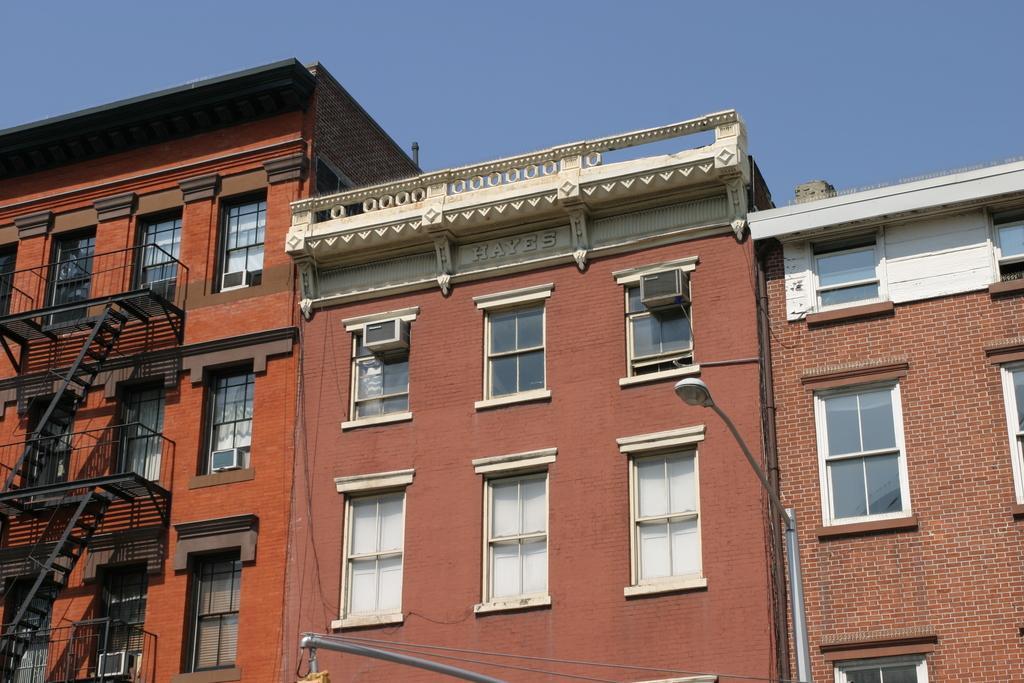Could you give a brief overview of what you see in this image? In this image I can see there is buildings and stairs attached to it. And there is a street light. And at the top there is a sky. 